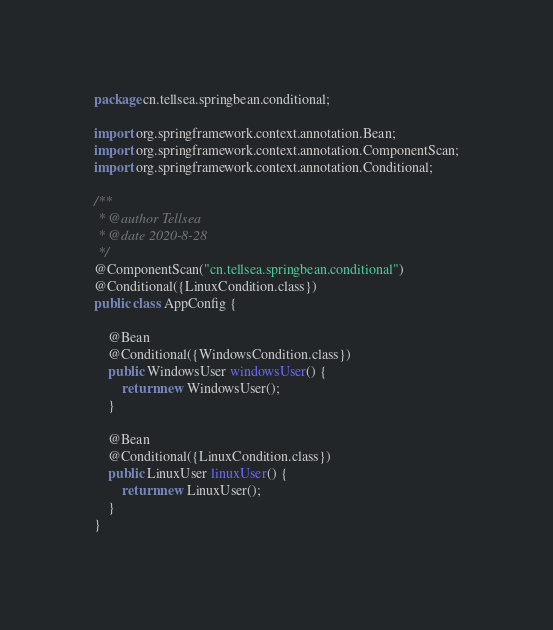Convert code to text. <code><loc_0><loc_0><loc_500><loc_500><_Java_>package cn.tellsea.springbean.conditional;

import org.springframework.context.annotation.Bean;
import org.springframework.context.annotation.ComponentScan;
import org.springframework.context.annotation.Conditional;

/**
 * @author Tellsea
 * @date 2020-8-28
 */
@ComponentScan("cn.tellsea.springbean.conditional")
@Conditional({LinuxCondition.class})
public class AppConfig {

	@Bean
	@Conditional({WindowsCondition.class})
	public WindowsUser windowsUser() {
		return new WindowsUser();
	}

	@Bean
	@Conditional({LinuxCondition.class})
	public LinuxUser linuxUser() {
		return new LinuxUser();
	}
}
</code> 